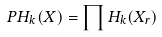<formula> <loc_0><loc_0><loc_500><loc_500>P H _ { k } ( X ) = \prod H _ { k } ( X _ { r } )</formula> 